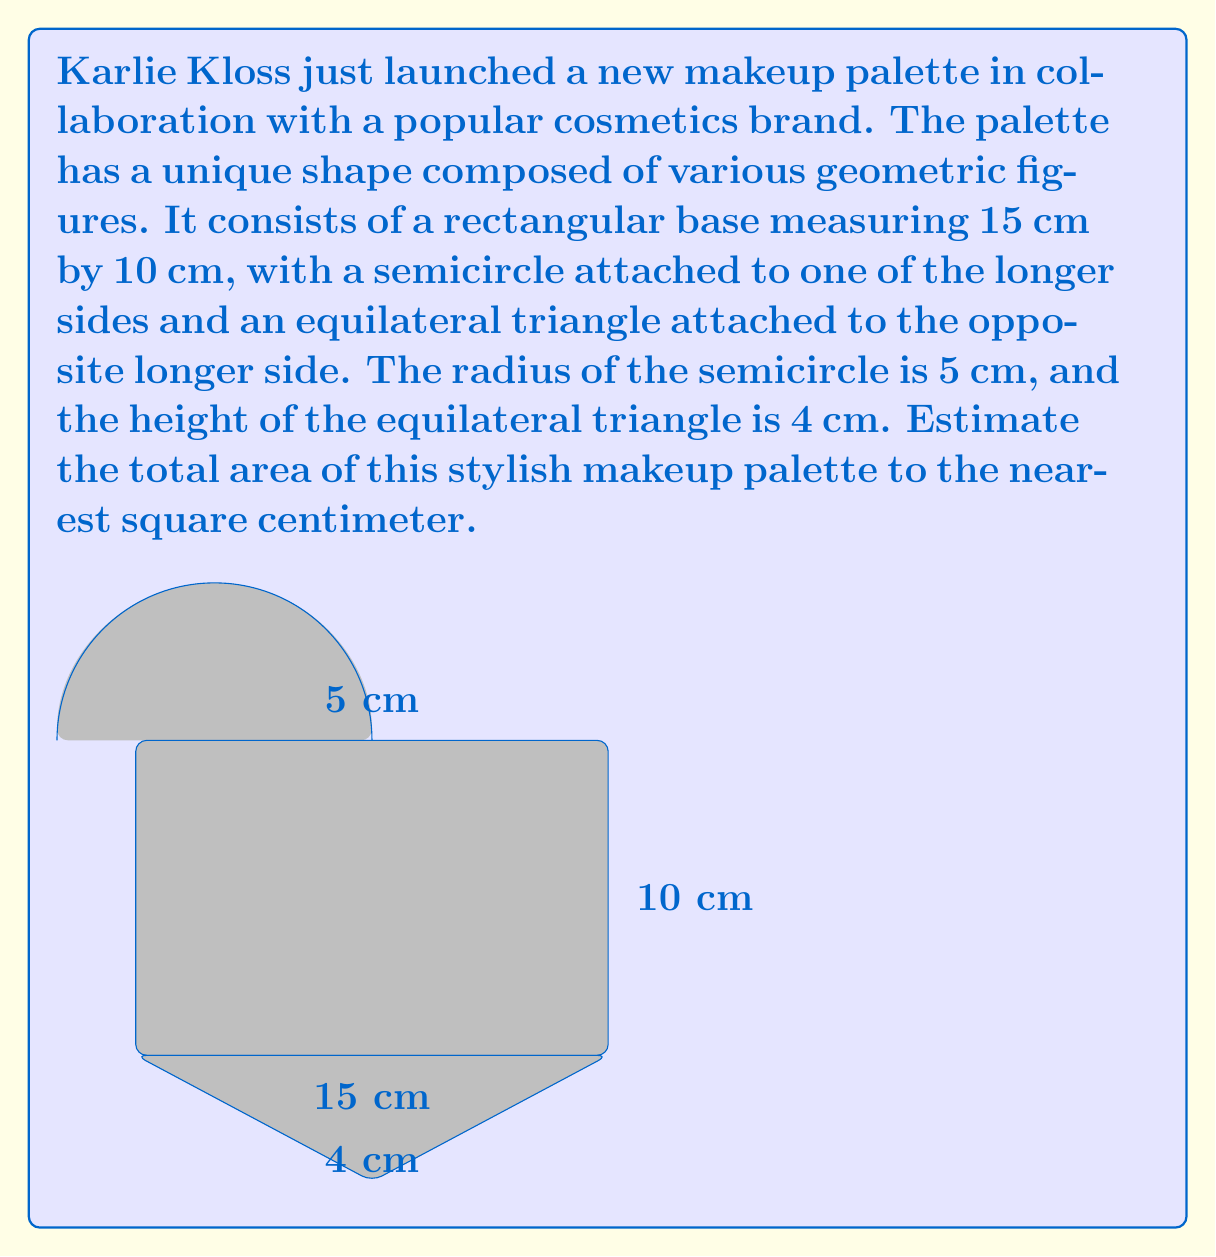Could you help me with this problem? To estimate the total area of the makeup palette, we need to calculate the areas of the rectangle, semicircle, and triangle separately, then sum them up.

1. Area of the rectangle:
   $A_r = l \times w = 15 \text{ cm} \times 10 \text{ cm} = 150 \text{ cm}^2$

2. Area of the semicircle:
   $A_s = \frac{1}{2} \times \pi r^2 = \frac{1}{2} \times \pi \times (5 \text{ cm})^2 \approx 39.27 \text{ cm}^2$

3. Area of the equilateral triangle:
   First, we need to calculate the base of the triangle. Since the height is 4 cm and it's an equilateral triangle, we can use the formula:
   $h = \frac{\sqrt{3}}{2}a$, where $h$ is the height and $a$ is the side length.
   
   $4 = \frac{\sqrt{3}}{2}a$
   $a = \frac{8}{\sqrt{3}} \approx 4.62 \text{ cm}$

   Now we can calculate the area of the triangle:
   $A_t = \frac{1}{2} \times \text{base} \times \text{height} = \frac{1}{2} \times 15 \text{ cm} \times 4 \text{ cm} = 30 \text{ cm}^2$

4. Total area:
   $A_{\text{total}} = A_r + A_s + A_t = 150 + 39.27 + 30 = 219.27 \text{ cm}^2$

Rounding to the nearest square centimeter, we get 219 cm².
Answer: The estimated total area of Karlie Kloss's makeup palette is approximately 219 cm². 